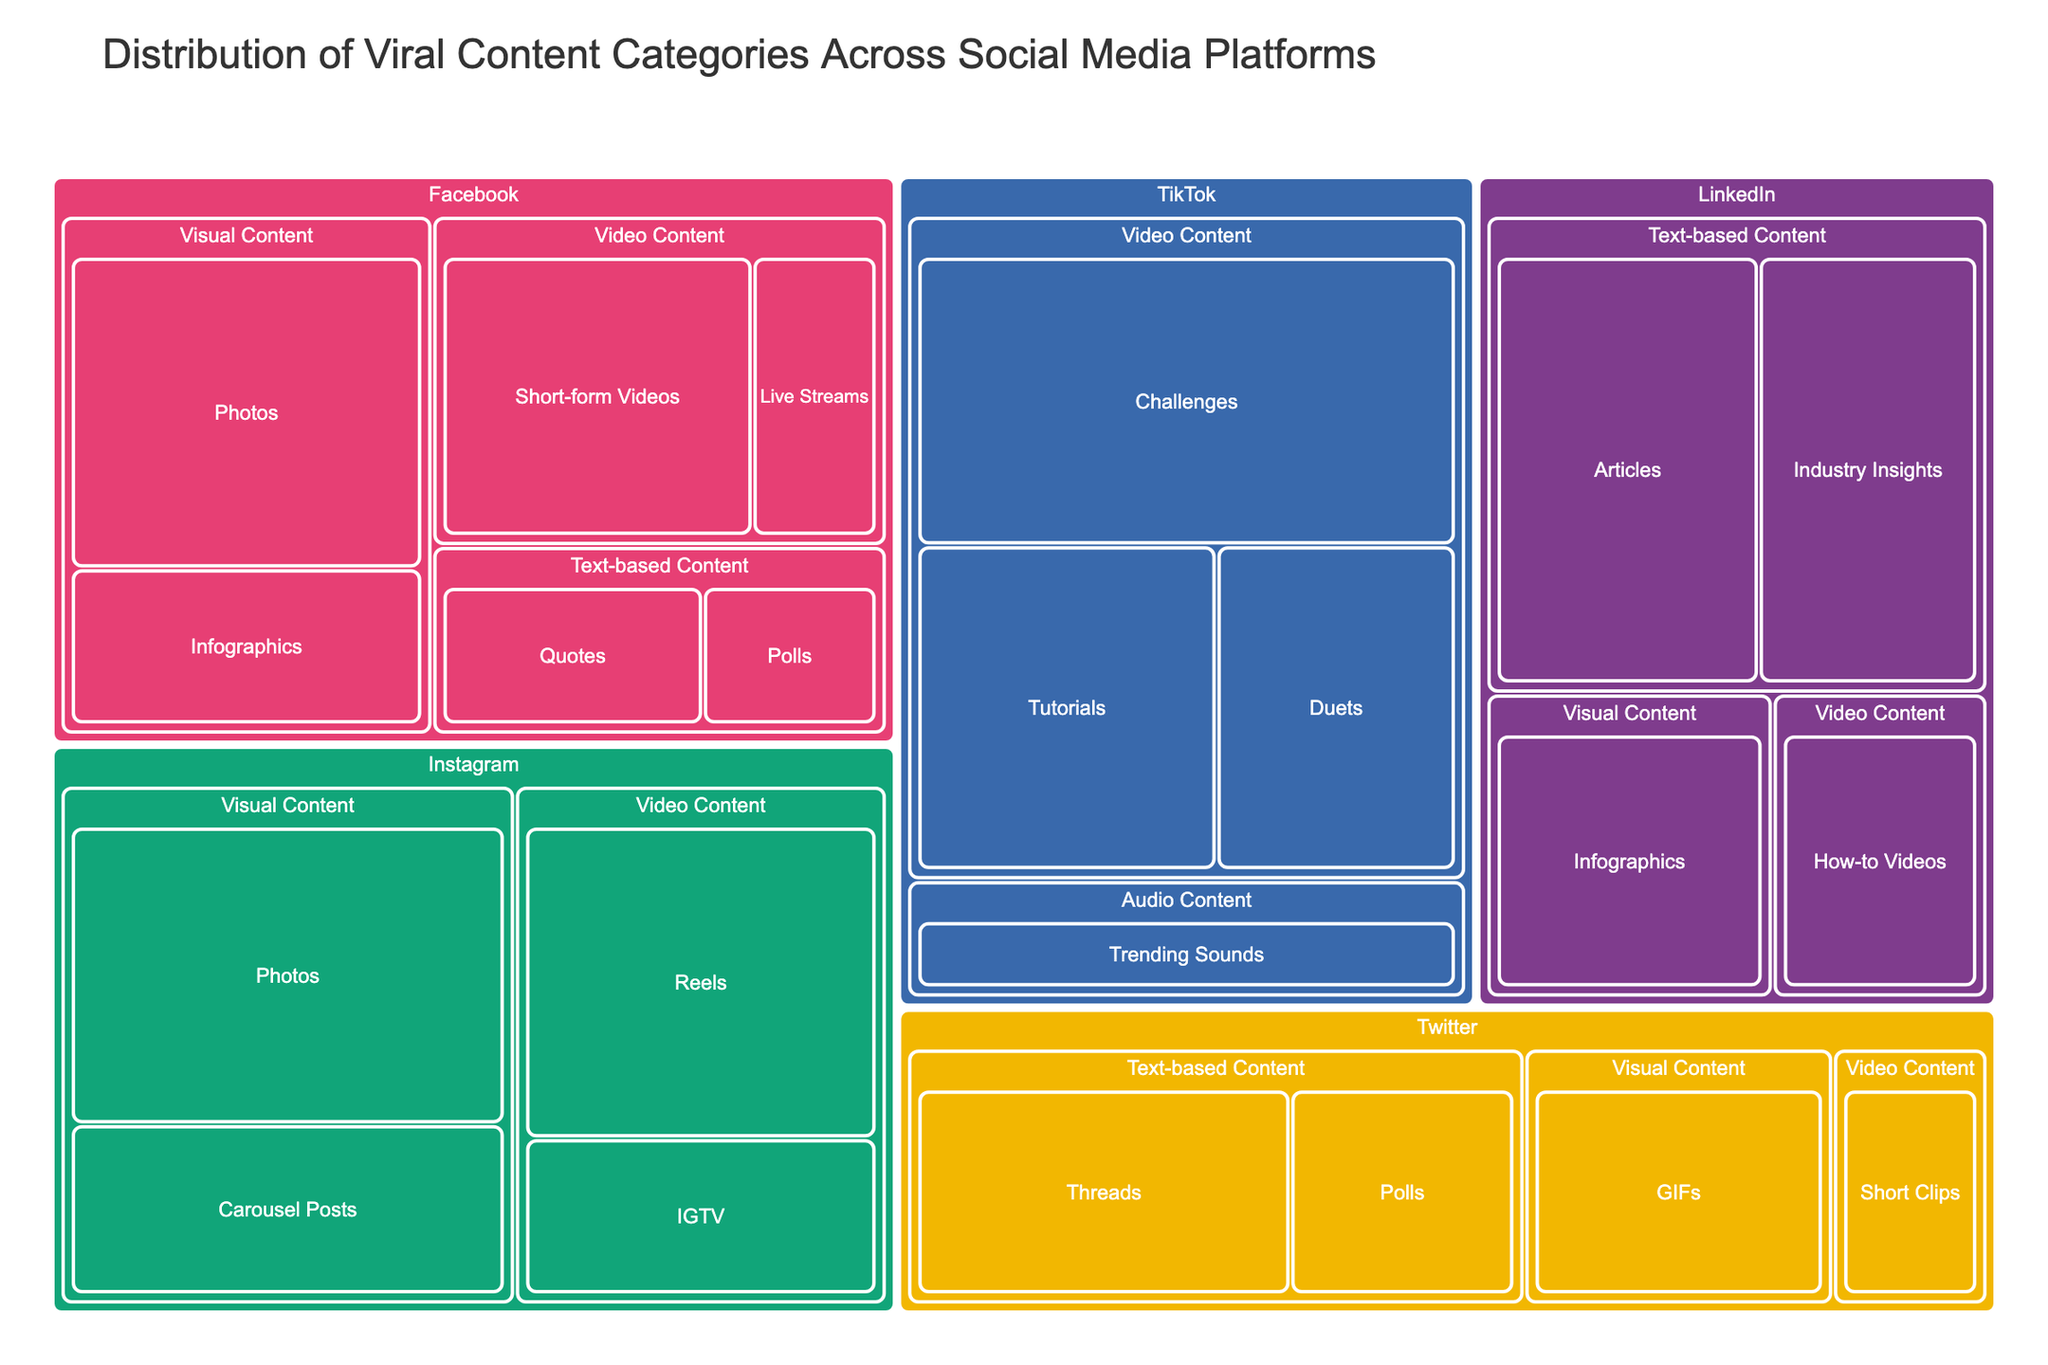How many subcategories are there under Facebook's Visual Content category? Facebook's Visual Content category is divided into two subcategories: Photos and Infographics.
Answer: 2 Which platform-subcategory pair has the highest value? The subcategory "Challenges" under the platform TikTok has a value of 40, which is the highest value in the treemap.
Answer: TikTok-Challenges What is the total value of Visual Content on Instagram? The values for Visual Content on Instagram are: Photos (35) and Carousel Posts (20). Summing these values gives a total of 35 + 20 = 55.
Answer: 55 Compare the values of Text-based Content Polls on Facebook and Twitter. Which one is higher? Facebook has a value of 8 for Text-based Content Polls, while Twitter has a value of 15. Therefore, Twitter's value is higher.
Answer: Twitter Between LinkedIn and Twitter, which platform has a higher total value for Text-based Content? For LinkedIn, the Text-based Content values are Articles (30) and Industry Insights (25), totaling 30 + 25 = 55. For Twitter, the values are Threads (25) and Polls (15), totaling 25 + 15 = 40. LinkedIn has the higher total value.
Answer: LinkedIn Which subcategory under Video Content has the second highest value, and on which platform is it found? The highest value under Video Content is TikTok's Challenges (40). The second highest is Instagram's Reels with a value of 30.
Answer: Instagram-Reels What is the combined value of all content subcategories on Facebook? The values for Facebook are: Photos (30), Infographics (15), Short-form Videos (25), Live Streams (10), Polls (8), and Quotes (12). Their combined value is 30 + 15 + 25 + 10 + 8 + 12 = 100.
Answer: 100 Which platform has the least variety of content categories? TikTok only has content under Video Content and Audio Content, which is fewer compared to other platforms that have three or more different content categories.
Answer: TikTok 